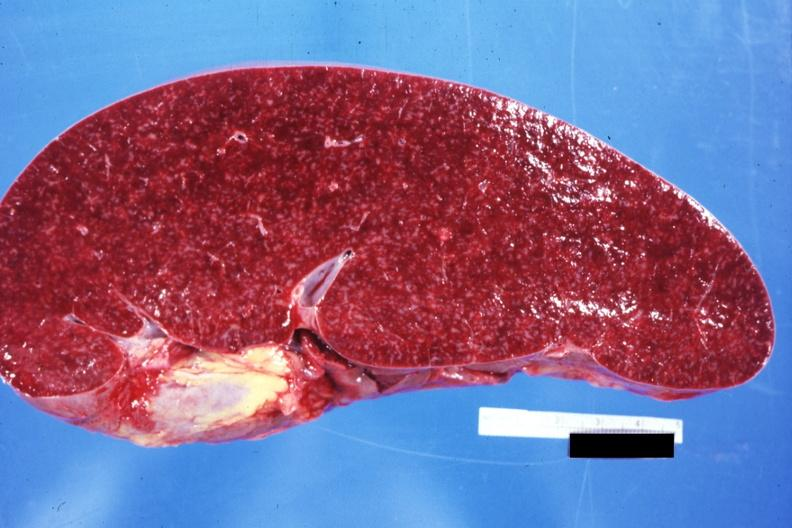how does normal see sides this case?
Answer the question using a single word or phrase. Other 